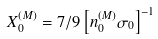<formula> <loc_0><loc_0><loc_500><loc_500>X _ { 0 } ^ { ( M ) } = 7 / 9 \left [ n _ { 0 } ^ { ( M ) } \sigma _ { 0 } \right ] ^ { - 1 }</formula> 